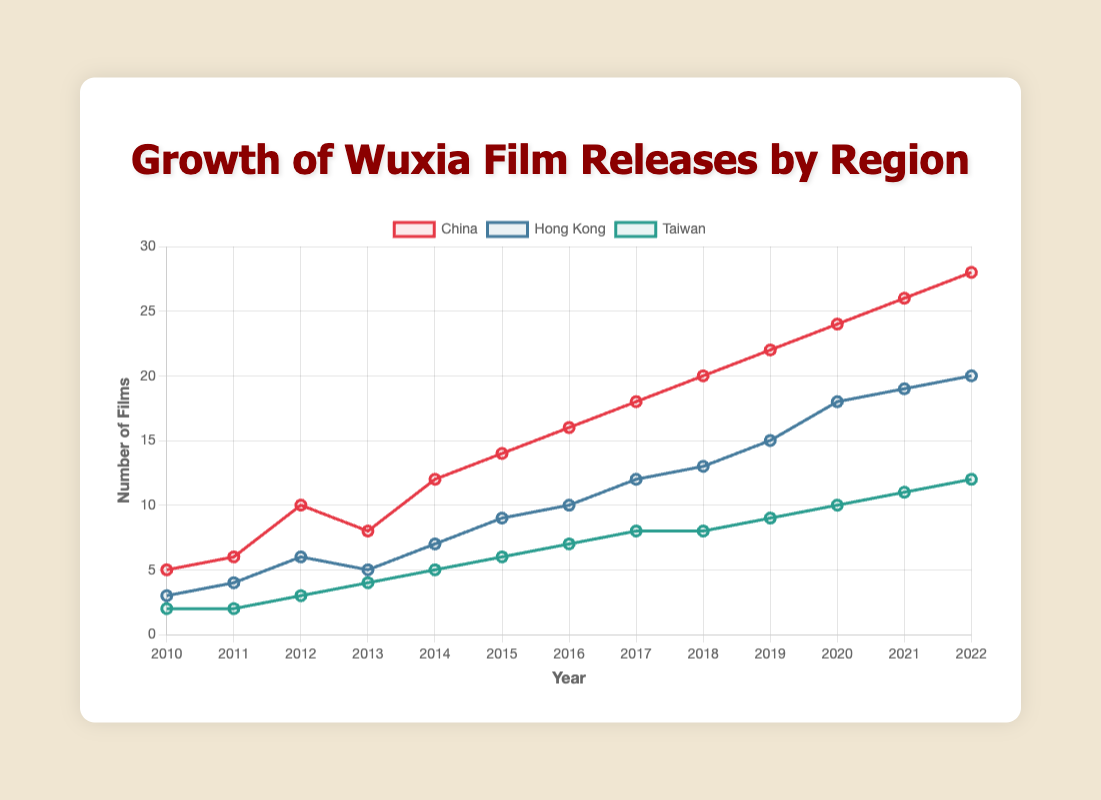What's the trend of Wuxia film releases in China from 2010 to 2022? The number of Wuxia film releases in China increased steadily each year from 5 in 2010 to 28 in 2022.
Answer: Rising Which region had the highest number of releases in 2022? By visually examining the lines at 2022, China had the highest number with 28 releases, followed by Hong Kong with 20 and Taiwan with 12.
Answer: China How did the growth in the number of Wuxia films released in Taiwan compare to Hong Kong between 2015 and 2020? From 2015 to 2020, Taiwan's releases increased from 6 to 10, a growth of 4 films. Hong Kong's releases increased from 9 to 18, a growth of 9 films.
Answer: Hong Kong grew more How many total Wuxia films were released in 2015 across all three regions? In 2015, China released 14, Hong Kong released 9, and Taiwan released 6 films. Sum: 14 + 9 + 6 = 29.
Answer: 29 Were there any years where the number of Wuxia films released in Hong Kong decreased? There is a slight decrease from 2012 (6 films) to 2013 (5 films), while other years show an increase or remain stable.
Answer: Yes, once By what percentage did the number of Wuxia films released in China increase from 2010 to 2022? The number of films increased from 5 in 2010 to 28 in 2022. The percentage increase is ((28 - 5) / 5) * 100 = 460%.
Answer: 460% What has the steadiest growth rate, China, Hong Kong, or Taiwan? By visual inspection, the line representing China shows a consistently increasing trend, whereas Hong Kong and Taiwan have some years of irregular growth.
Answer: China Which region had more Wuxia film releases in 2017, Hong Kong or Taiwan? In 2017, Hong Kong released 12 films, and Taiwan released 8 films.
Answer: Hong Kong What color represents the data for Wuxia films released in Taiwan? The color representing Taiwan is green, as indicated by the line color corresponding to Taiwan in the legend.
Answer: Green 